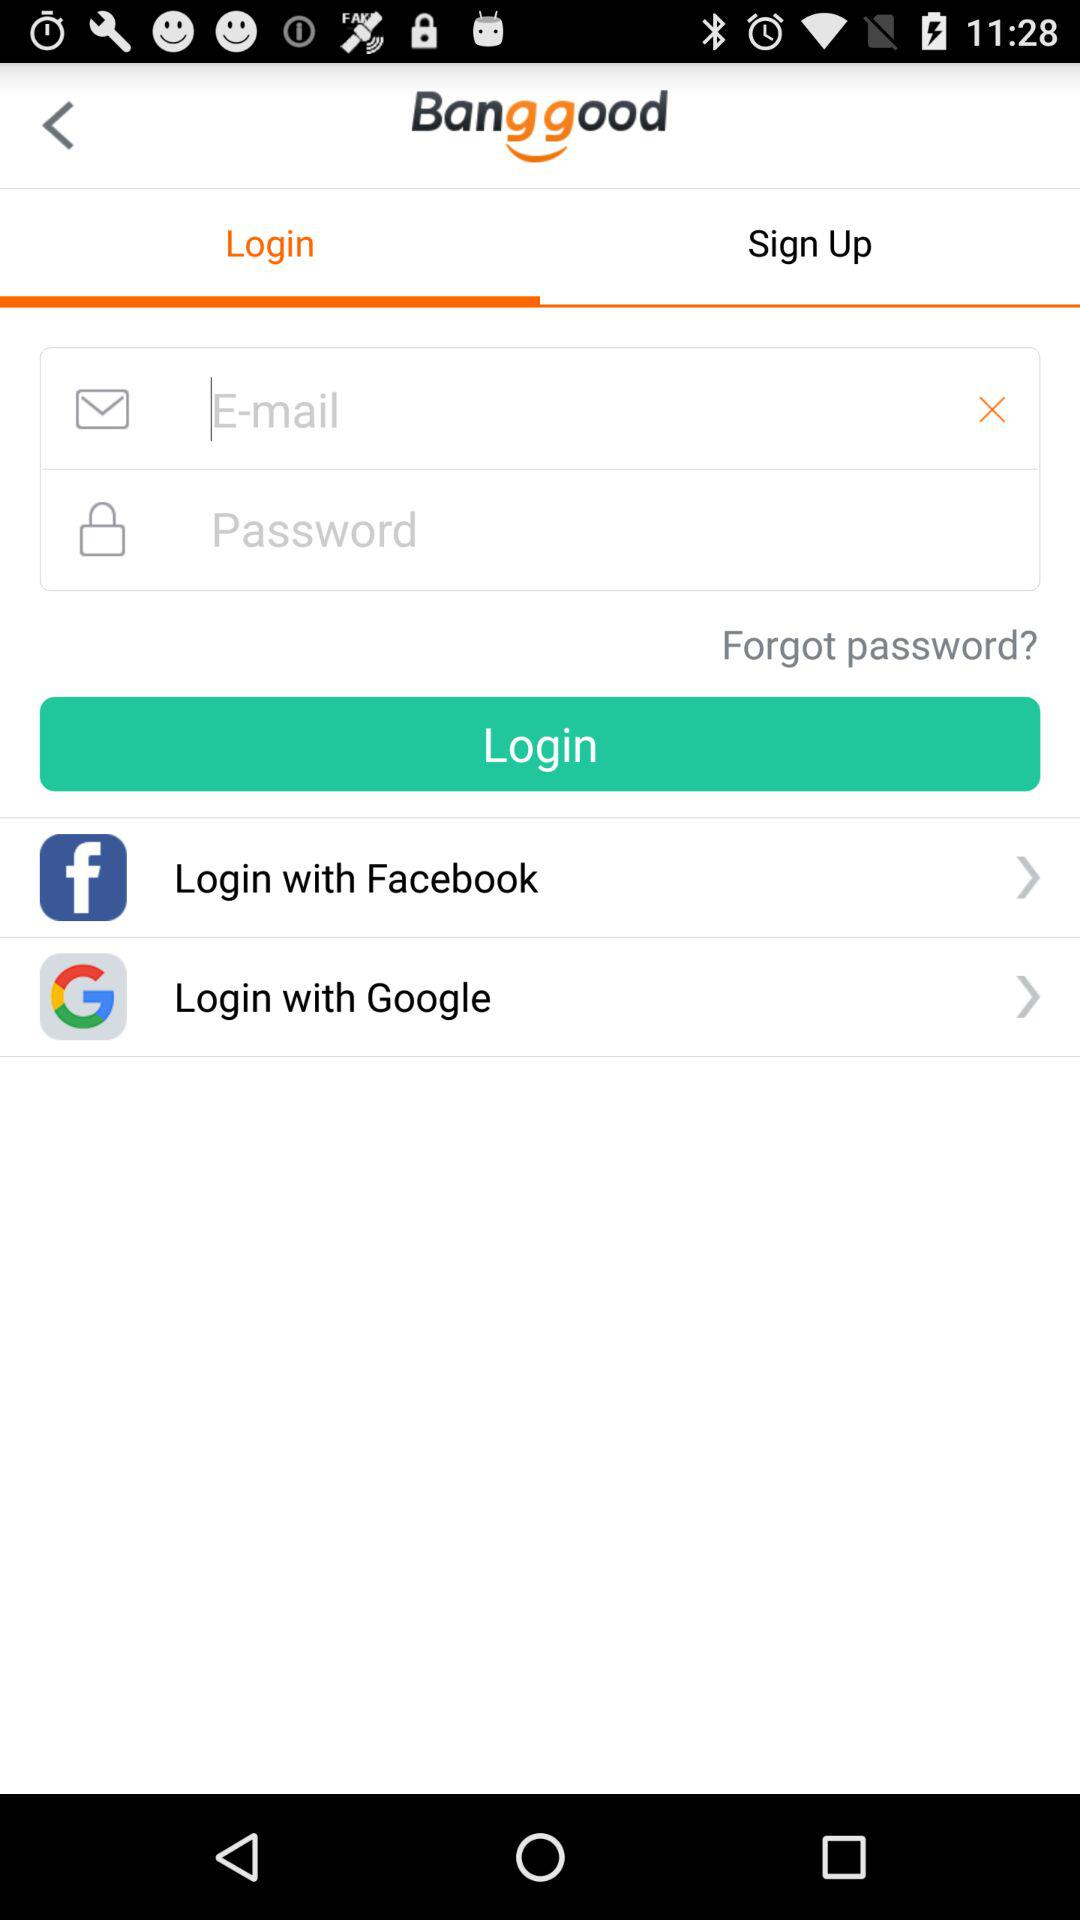What is the application name? The application name is "Banggood". 